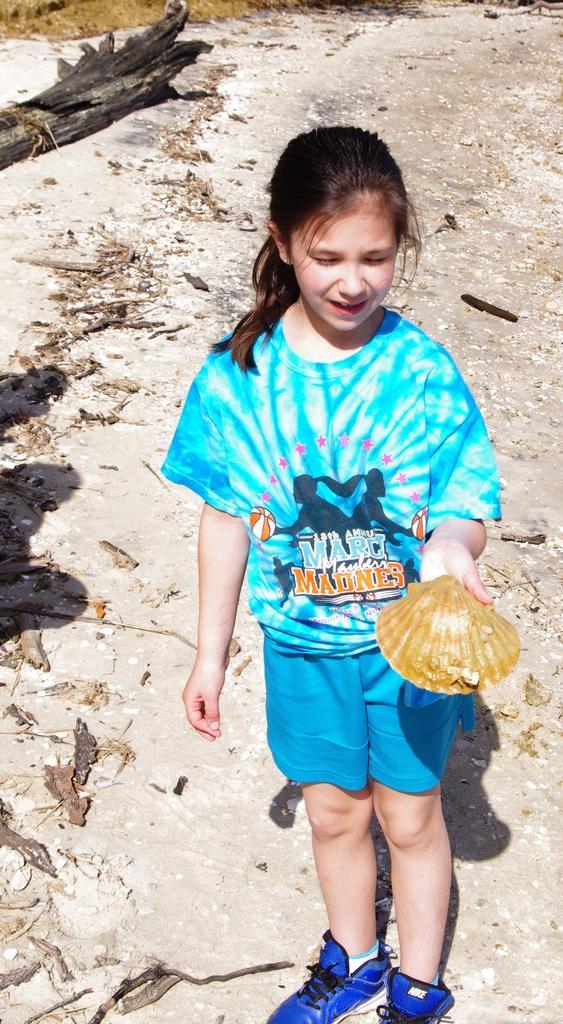In one or two sentences, can you explain what this image depicts? This image is taken outdoors. At the bottom of the image there is a ground with a few dry leaves. In the background there is a bark on the ground. In the middle of the image a girl is standing on the ground and she is holding a shell in her hand. 